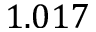Convert formula to latex. <formula><loc_0><loc_0><loc_500><loc_500>1 . 0 1 7</formula> 